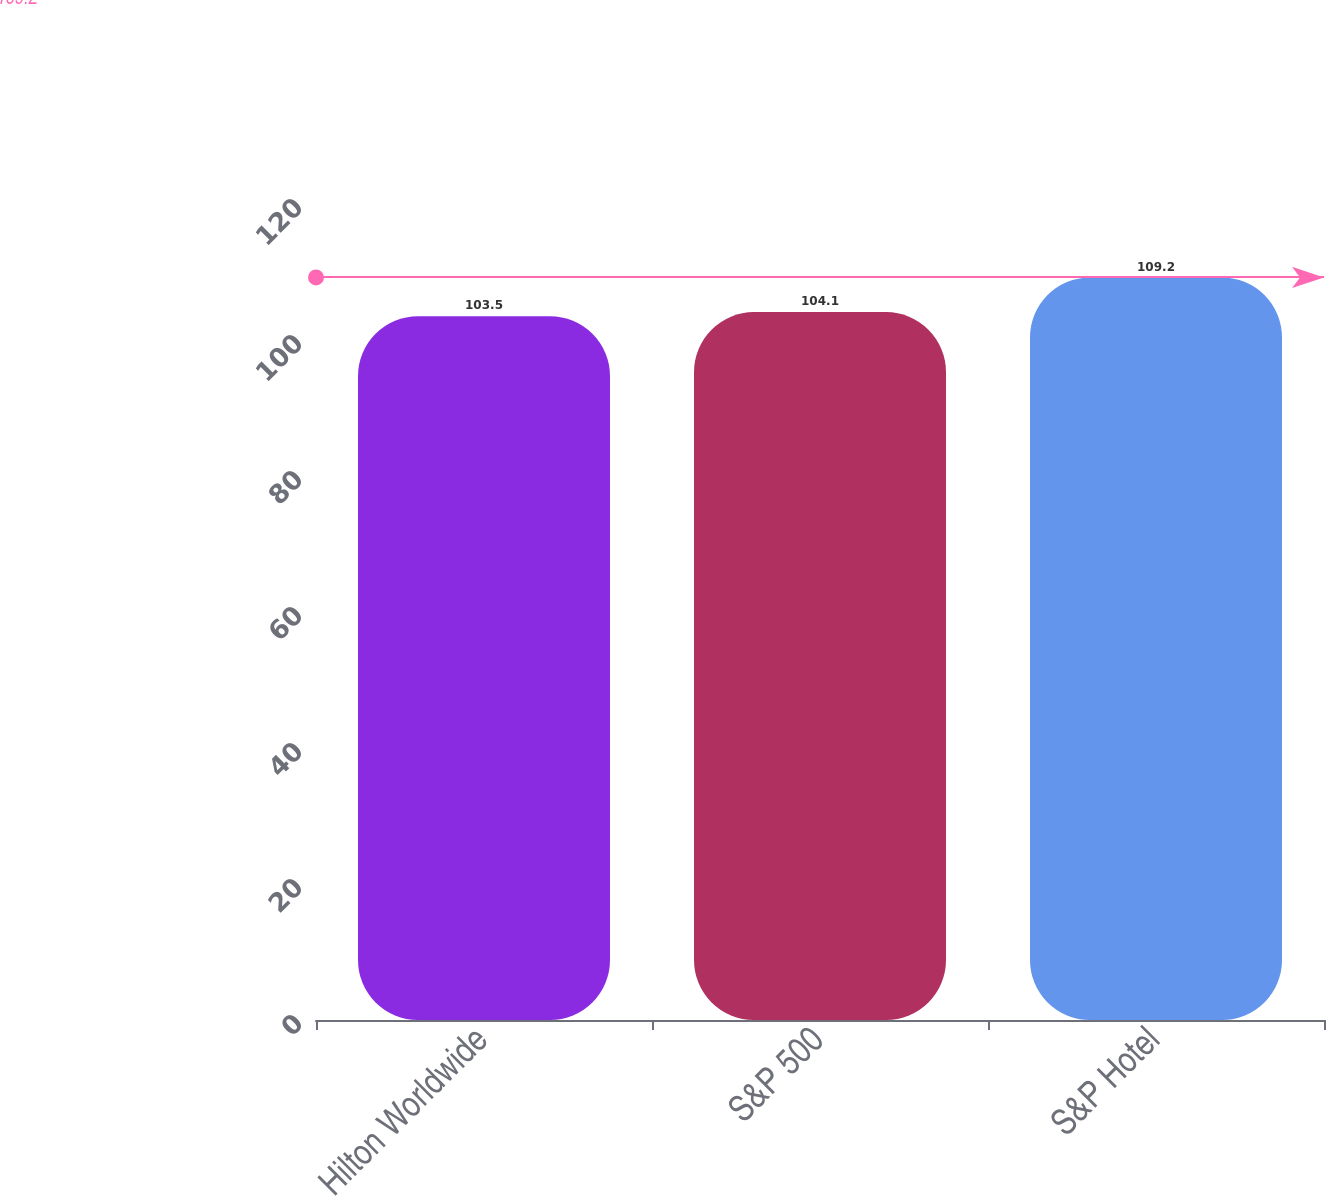<chart> <loc_0><loc_0><loc_500><loc_500><bar_chart><fcel>Hilton Worldwide<fcel>S&P 500<fcel>S&P Hotel<nl><fcel>103.5<fcel>104.1<fcel>109.2<nl></chart> 